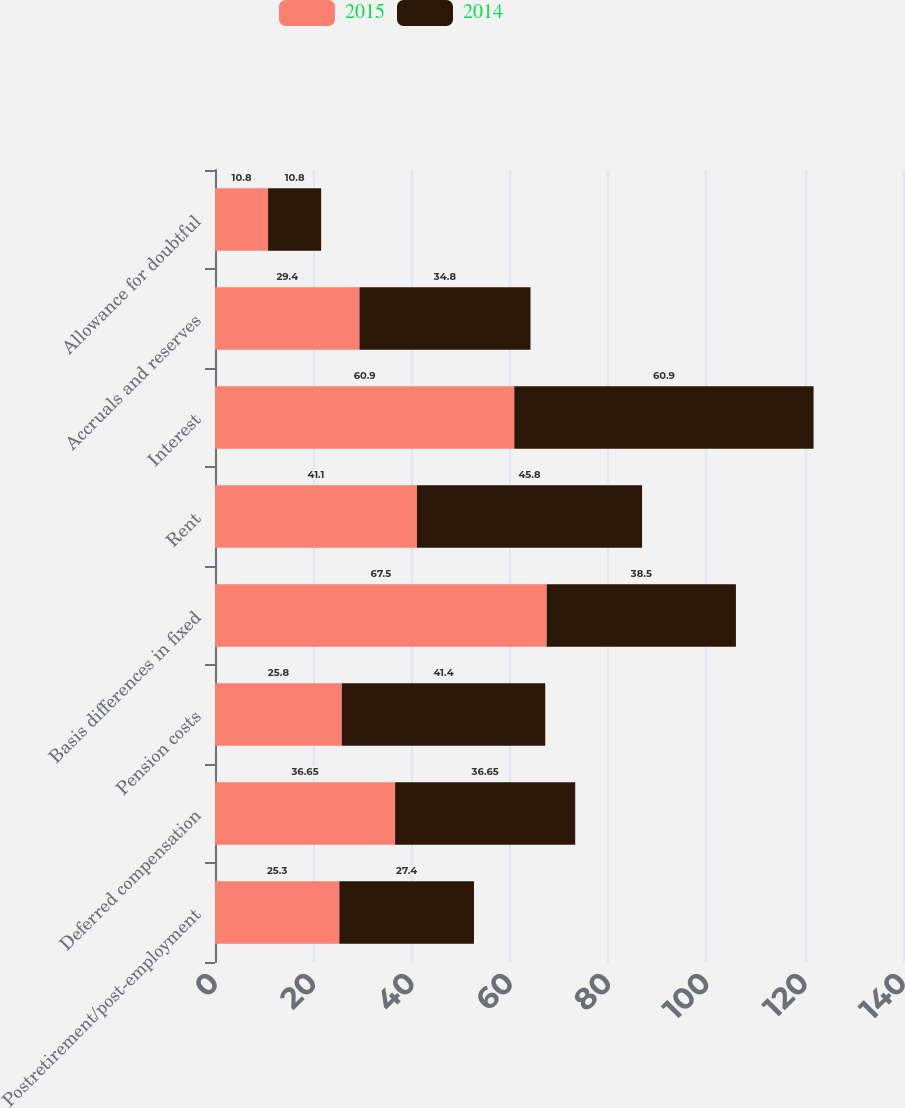<chart> <loc_0><loc_0><loc_500><loc_500><stacked_bar_chart><ecel><fcel>Postretirement/post-employment<fcel>Deferred compensation<fcel>Pension costs<fcel>Basis differences in fixed<fcel>Rent<fcel>Interest<fcel>Accruals and reserves<fcel>Allowance for doubtful<nl><fcel>2015<fcel>25.3<fcel>36.65<fcel>25.8<fcel>67.5<fcel>41.1<fcel>60.9<fcel>29.4<fcel>10.8<nl><fcel>2014<fcel>27.4<fcel>36.65<fcel>41.4<fcel>38.5<fcel>45.8<fcel>60.9<fcel>34.8<fcel>10.8<nl></chart> 